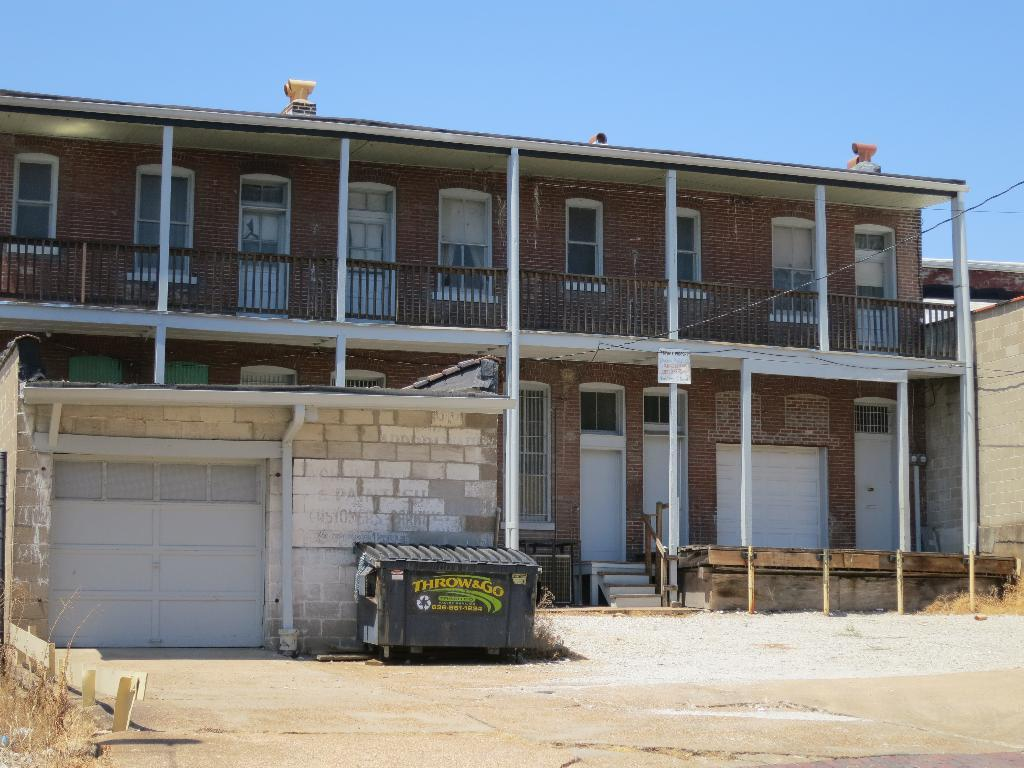What type of structure is visible in the image? There is a building and a house in the image. Are there any architectural features present in the image? Yes, there are steps and a fence in the image. What can be seen in the background of the image? The sky is visible in the background of the image. What is the purpose of the garbage bin in the image? The garbage bin is likely used for disposing of waste. What hobbies do the people in the image engage in during their journey? There are no people visible in the image, and therefore no hobbies or journey can be observed. 